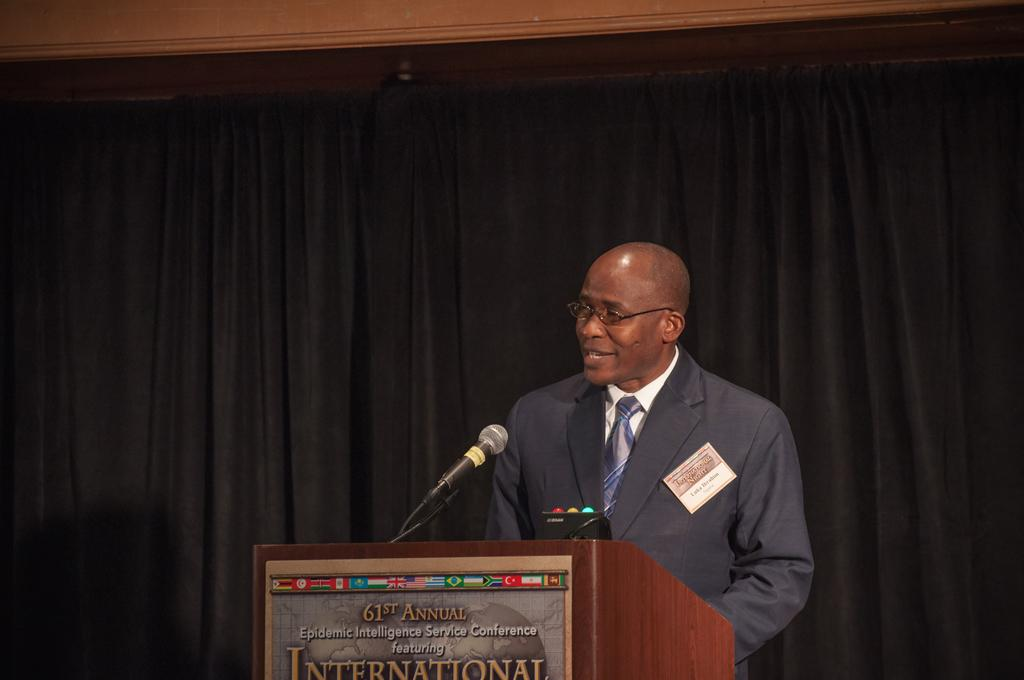What is the person in the image doing near the podium? The person is standing near a podium in the image. What object is present in the image that might be used for delivering a speech or presentation? A speaker is present in the image. What color are the curtains in the background of the image? The background is covered with black curtains. How many letters are visible on the person's feet in the image? There are no letters visible on the person's feet in the image. 